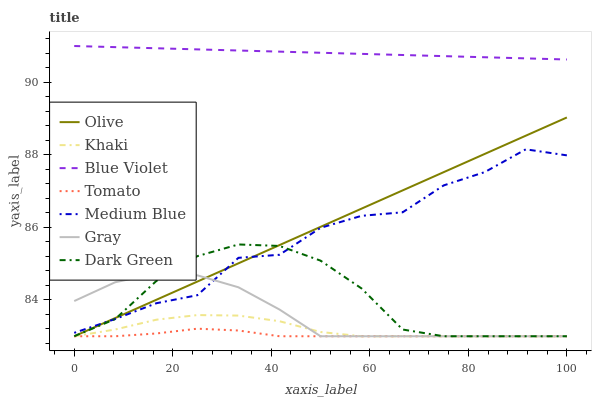Does Gray have the minimum area under the curve?
Answer yes or no. No. Does Gray have the maximum area under the curve?
Answer yes or no. No. Is Gray the smoothest?
Answer yes or no. No. Is Gray the roughest?
Answer yes or no. No. Does Medium Blue have the lowest value?
Answer yes or no. No. Does Gray have the highest value?
Answer yes or no. No. Is Dark Green less than Blue Violet?
Answer yes or no. Yes. Is Blue Violet greater than Olive?
Answer yes or no. Yes. Does Dark Green intersect Blue Violet?
Answer yes or no. No. 